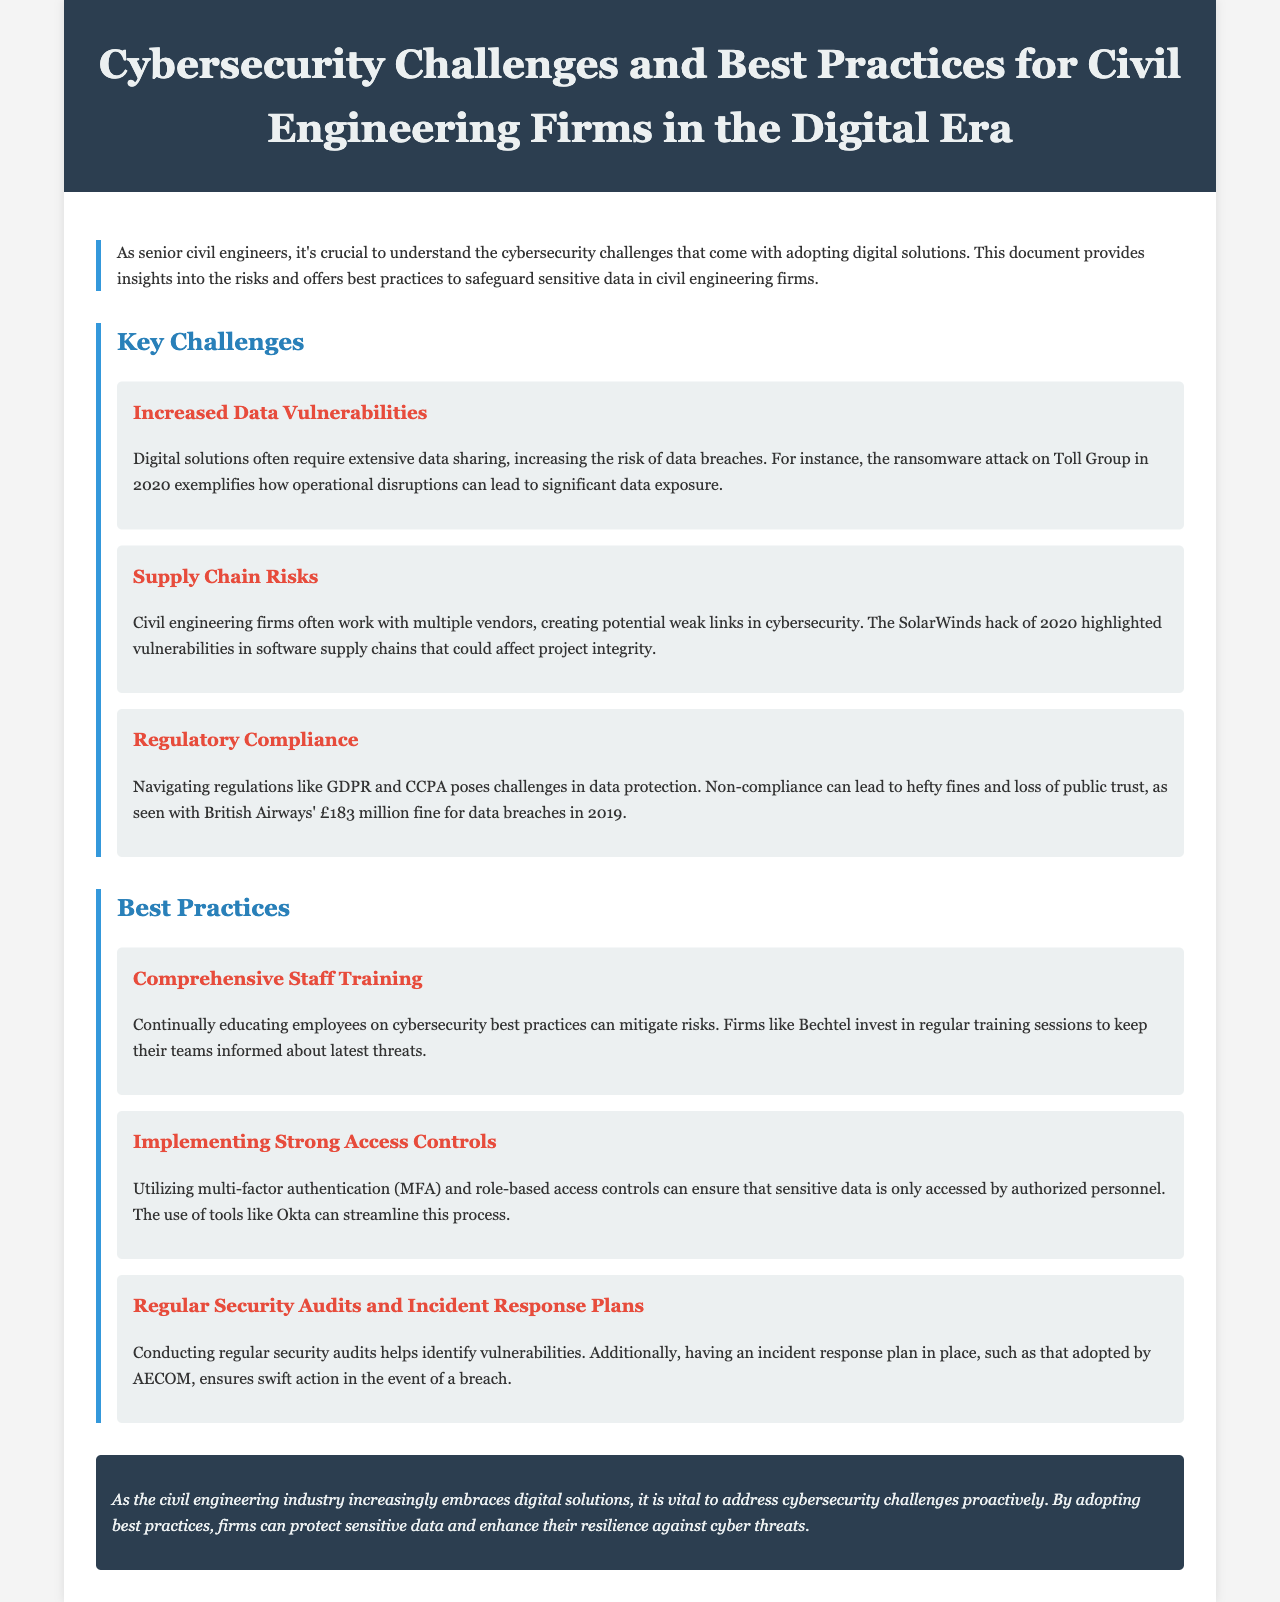What is the title of the newsletter? The title is explicitly stated in the header of the newsletter document.
Answer: Cybersecurity Challenges and Best Practices for Civil Engineering Firms in the Digital Era What year did the Toll Group experience a ransomware attack? The document mentions the year of the Toll Group attack as part of the example given for increased data vulnerabilities.
Answer: 2020 What regulation is mentioned that poses challenges in data protection? The document explicitly lists regulations that firms must navigate regarding data protection.
Answer: GDPR Which civil engineering firm invests in regular cybersecurity training sessions? The document provides a specific example of a firm that prioritizes staff training in cybersecurity.
Answer: Bechtel What is one method recommended for ensuring sensitive data access is controlled? This is outlined as a key strategy in the best practices section of the newsletter.
Answer: Multi-factor authentication Which company adopted an incident response plan as mentioned in the best practices section? This information is specifically provided in the section regarding security audits and incident response.
Answer: AECOM What color is used for the title's background? The title's background color is noted in the style section of the document.
Answer: Dark blue How many key challenges are listed in the newsletter? The number of key challenges is specified in the section discussing them.
Answer: Three 